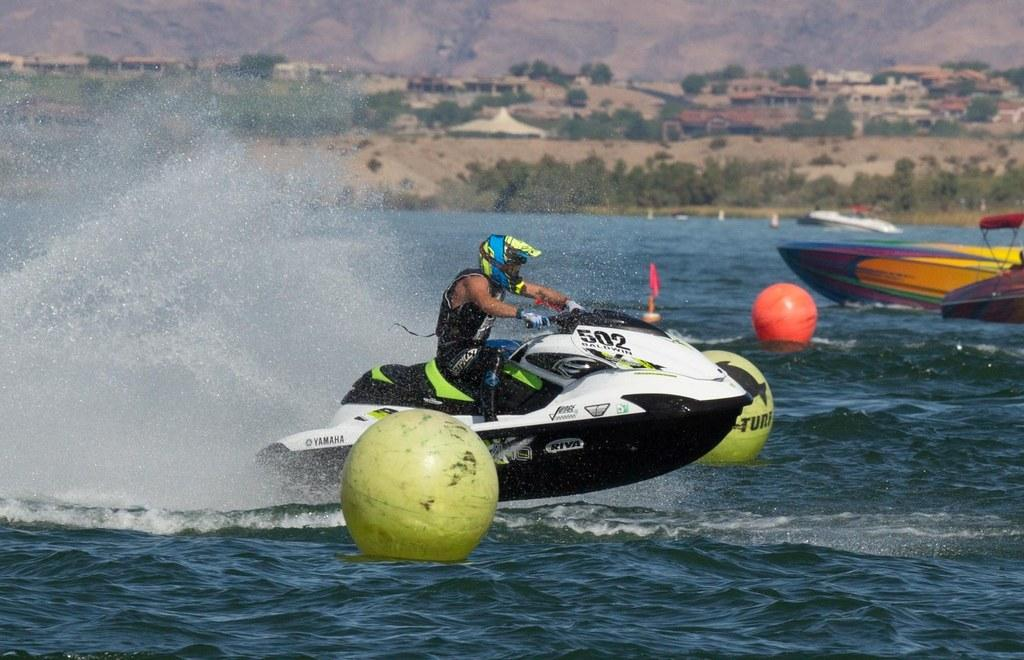What is in the foreground of the picture? There is water in the foreground of the picture. What objects can be seen in the water? There are balls and boats in the water. Is there any human presence in the water? Yes, there is a person on a motorbike in the water. What can be seen in the background of the picture? There are trees, buildings, and a hill in the background of the picture. What type of pencil can be seen floating in the water? There is no pencil present in the image; it is a picture of water with balls, boats, and a person on a motorbike. 